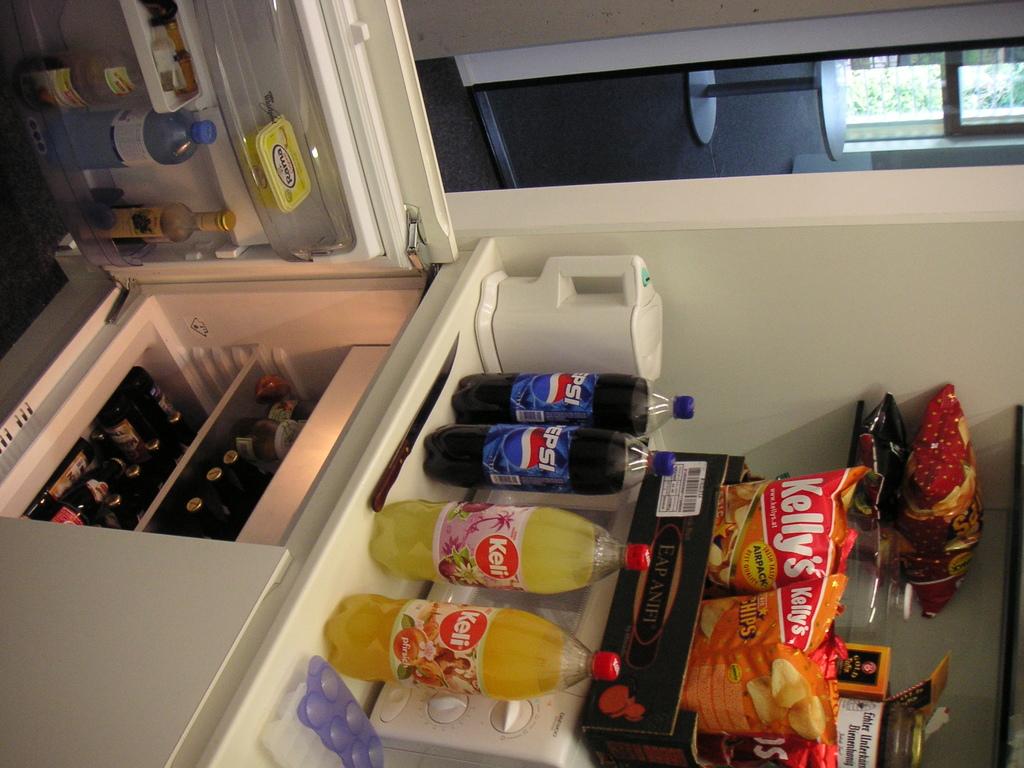What is the brand of the chips?
Your answer should be very brief. Kelly's. This is juice and chackiet?
Offer a very short reply. Unanswerable. 